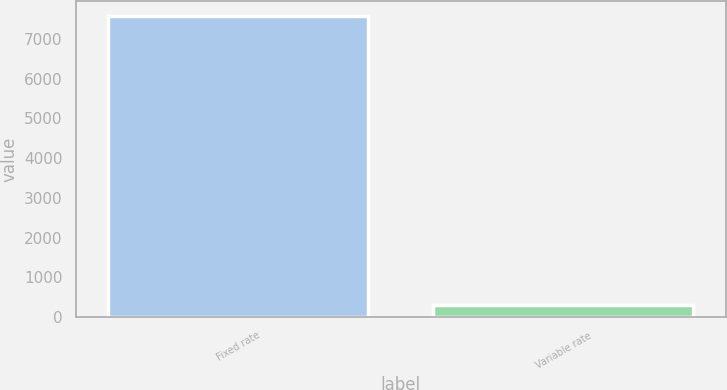<chart> <loc_0><loc_0><loc_500><loc_500><bar_chart><fcel>Fixed rate<fcel>Variable rate<nl><fcel>7570<fcel>304<nl></chart> 